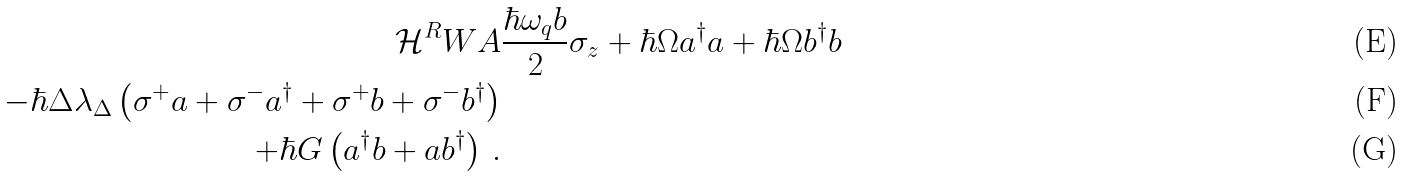<formula> <loc_0><loc_0><loc_500><loc_500>\mathcal { H } ^ { R } W A & \frac { \hbar { \omega } _ { q } b } { 2 } \sigma _ { z } + \hbar { \Omega } a ^ { \dagger } a + \hbar { \Omega } b ^ { \dagger } b \\ - \hbar { \Delta } \lambda _ { \Delta } \left ( \sigma ^ { + } a + \sigma ^ { - } a ^ { \dagger } + \sigma ^ { + } b + \sigma ^ { - } b ^ { \dagger } \right ) \\ + \hbar { G } \left ( a ^ { \dagger } b + a b ^ { \dagger } \right ) \, .</formula> 